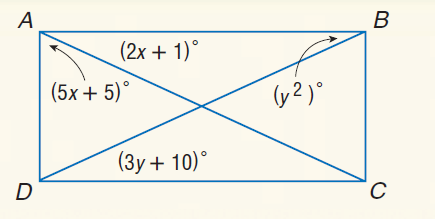Answer the mathemtical geometry problem and directly provide the correct option letter.
Question: Quadrilateral A B C D is a rectangle. Find y.
Choices: A: 5 B: 12 C: 24 D: 25 A 